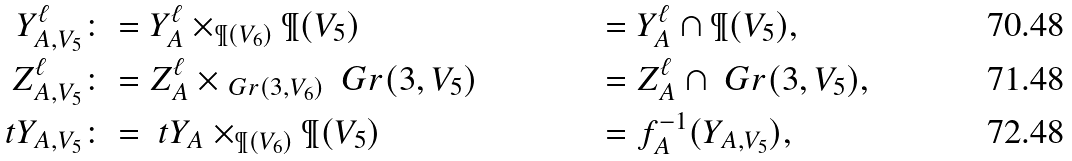<formula> <loc_0><loc_0><loc_500><loc_500>Y ^ { \ell } _ { A , V _ { 5 } } & \colon = Y ^ { \ell } _ { A } \times _ { \P ( V _ { 6 } ) } \P ( V _ { 5 } ) & & = Y ^ { \ell } _ { A } \cap \P ( V _ { 5 } ) , \\ Z ^ { \ell } _ { A , V _ { 5 } } & \colon = Z ^ { \ell } _ { A } \times _ { \ G r ( 3 , V _ { 6 } ) } \ G r ( 3 , V _ { 5 } ) & & = Z ^ { \ell } _ { A } \cap \ G r ( 3 , V _ { 5 } ) , \\ \ t Y _ { A , V _ { 5 } } & \colon = \ t Y _ { A } \times _ { \P ( V _ { 6 } ) } \P ( V _ { 5 } ) & & = f _ { A } ^ { - 1 } ( Y _ { A , V _ { 5 } } ) ,</formula> 